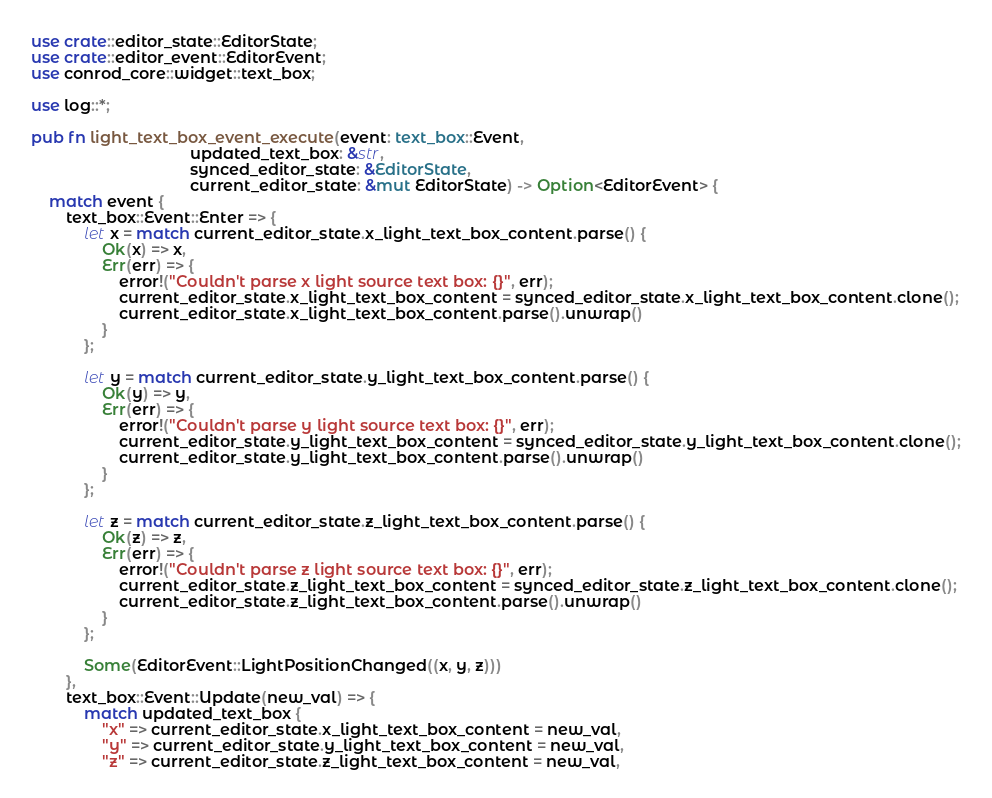Convert code to text. <code><loc_0><loc_0><loc_500><loc_500><_Rust_>use crate::editor_state::EditorState;
use crate::editor_event::EditorEvent;
use conrod_core::widget::text_box;

use log::*;

pub fn light_text_box_event_execute(event: text_box::Event, 
                                    updated_text_box: &str,
                                    synced_editor_state: &EditorState, 
                                    current_editor_state: &mut EditorState) -> Option<EditorEvent> {
    match event {
        text_box::Event::Enter => {
            let x = match current_editor_state.x_light_text_box_content.parse() {
                Ok(x) => x,
                Err(err) => {
                    error!("Couldn't parse x light source text box: {}", err);
                    current_editor_state.x_light_text_box_content = synced_editor_state.x_light_text_box_content.clone();
                    current_editor_state.x_light_text_box_content.parse().unwrap()
                }
            };

            let y = match current_editor_state.y_light_text_box_content.parse() {
                Ok(y) => y,
                Err(err) => {
                    error!("Couldn't parse y light source text box: {}", err);
                    current_editor_state.y_light_text_box_content = synced_editor_state.y_light_text_box_content.clone();
                    current_editor_state.y_light_text_box_content.parse().unwrap()
                }
            };

            let z = match current_editor_state.z_light_text_box_content.parse() {
                Ok(z) => z,
                Err(err) => {
                    error!("Couldn't parse z light source text box: {}", err);
                    current_editor_state.z_light_text_box_content = synced_editor_state.z_light_text_box_content.clone();
                    current_editor_state.z_light_text_box_content.parse().unwrap()
                }
            };

            Some(EditorEvent::LightPositionChanged((x, y, z)))
        },
        text_box::Event::Update(new_val) => {
            match updated_text_box {
                "x" => current_editor_state.x_light_text_box_content = new_val,
                "y" => current_editor_state.y_light_text_box_content = new_val,
                "z" => current_editor_state.z_light_text_box_content = new_val,</code> 